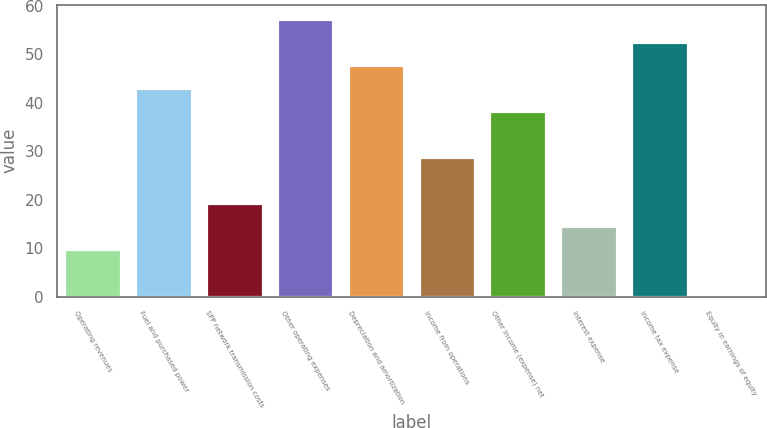Convert chart to OTSL. <chart><loc_0><loc_0><loc_500><loc_500><bar_chart><fcel>Operating revenues<fcel>Fuel and purchased power<fcel>SPP network transmission costs<fcel>Other operating expenses<fcel>Depreciation and amortization<fcel>Income from operations<fcel>Other income (expense) net<fcel>Interest expense<fcel>Income tax expense<fcel>Equity in earnings of equity<nl><fcel>9.72<fcel>43.04<fcel>19.24<fcel>57.32<fcel>47.8<fcel>28.76<fcel>38.28<fcel>14.48<fcel>52.56<fcel>0.2<nl></chart> 